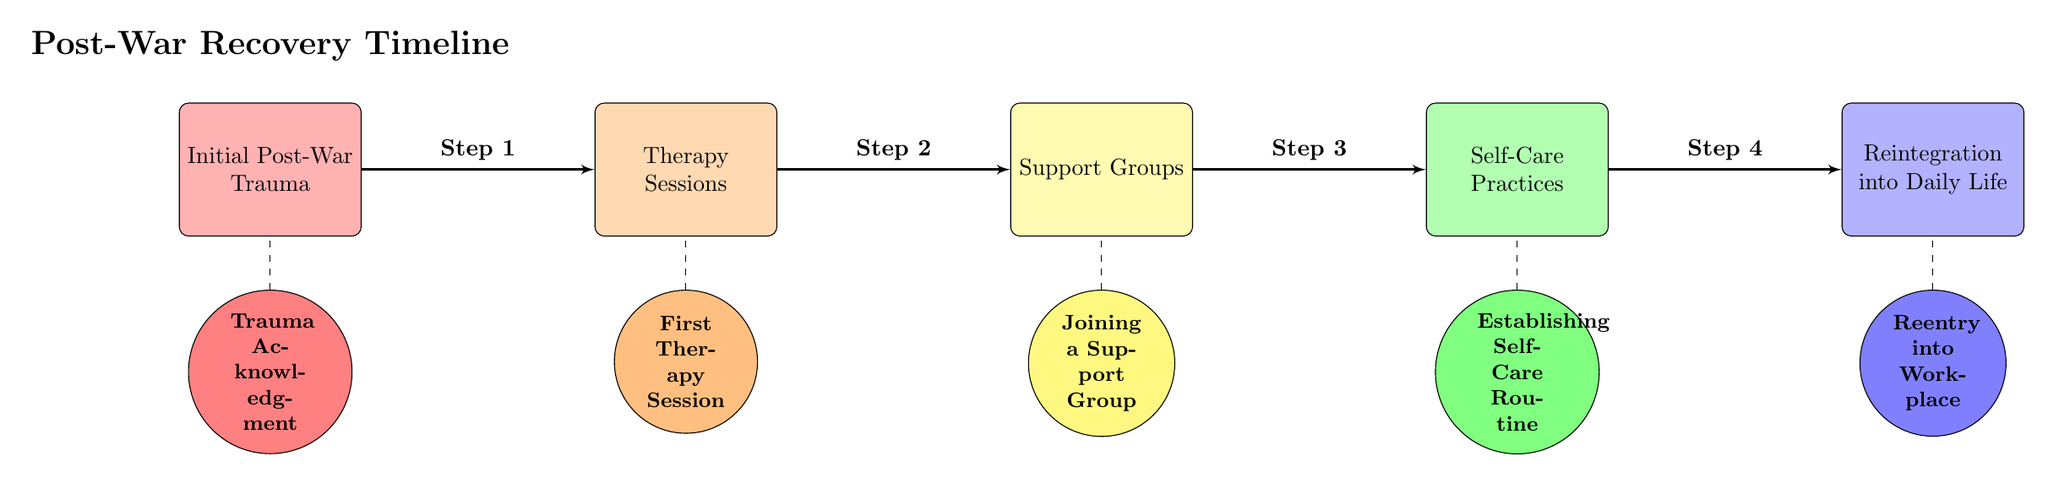What's the first stage of the recovery timeline? The first stage is identified in the diagram as "Initial Post-War Trauma." This is the starting block on the left, indicating the beginning of the recovery process after experiencing trauma.
Answer: Initial Post-War Trauma How many main stages are depicted in the diagram? To find the number of main stages, I count the distinct blocks from left to right. The blocks are: "Initial Post-War Trauma," "Therapy Sessions," "Support Groups," "Self-Care Practices," and "Reintegration into Daily Life." That totals to five stages.
Answer: 5 What milestone corresponds to therapy sessions? The milestone associated with therapy sessions is noted directly below the "Therapy Sessions" block as "First Therapy Session." This connects the therapy phase with its specific milestone for clarity.
Answer: First Therapy Session Which stage comes after support groups? In the diagram, the stage that follows "Support Groups" is "Self-Care Practices." The arrows show a directional flow from one stage to the next, indicating the sequence of the recovery process.
Answer: Self-Care Practices What color represents the reintegration stage? The "Reintegration into Daily Life" stage is represented by a blue color, as shown in the block filling. Each stage has a specific color, making it easier to differentiate them visually.
Answer: Blue What is the fourth step in the recovery timeline? The timeline indicates steps in order, and after following the connections, the fourth step, which corresponds to the block after "Support Groups," is identified as "Self-Care Practices."
Answer: Step 4 What is the purpose of the dashed lines in the diagram? The dashed lines connect each milestone to the corresponding block above it. This indicates that these milestones are significant moments within each stage, showing a relationship between a specific event and its stage in the recovery timeline.
Answer: Connect milestones Which milestone indicates entering the workforce? The milestone for reentering the workforce is described as "Reentry into Workplace," which appears directly below the last stage "Reintegration into Daily Life," marking a significant point in the recovery process.
Answer: Reentry into Workplace 